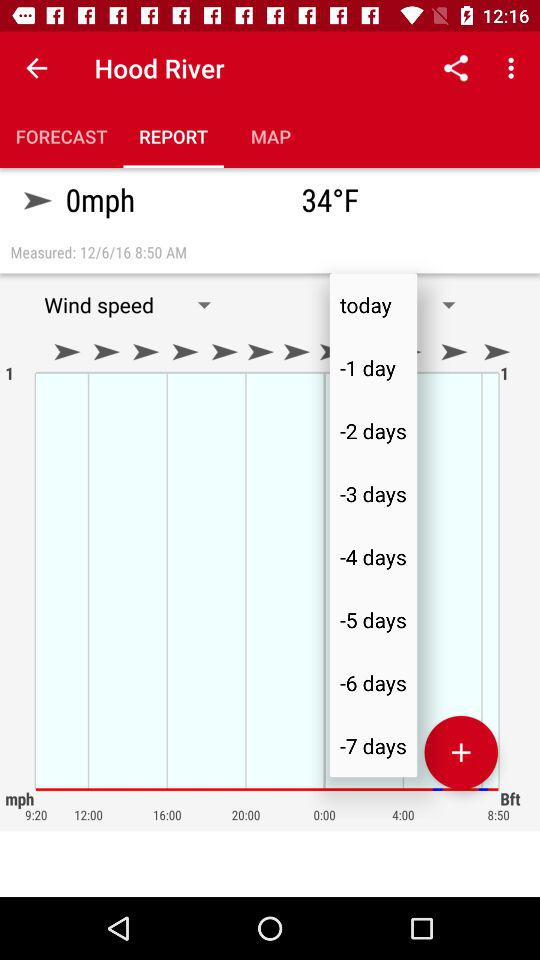On what date was the data measured? The data was measured on December 6, 2016. 